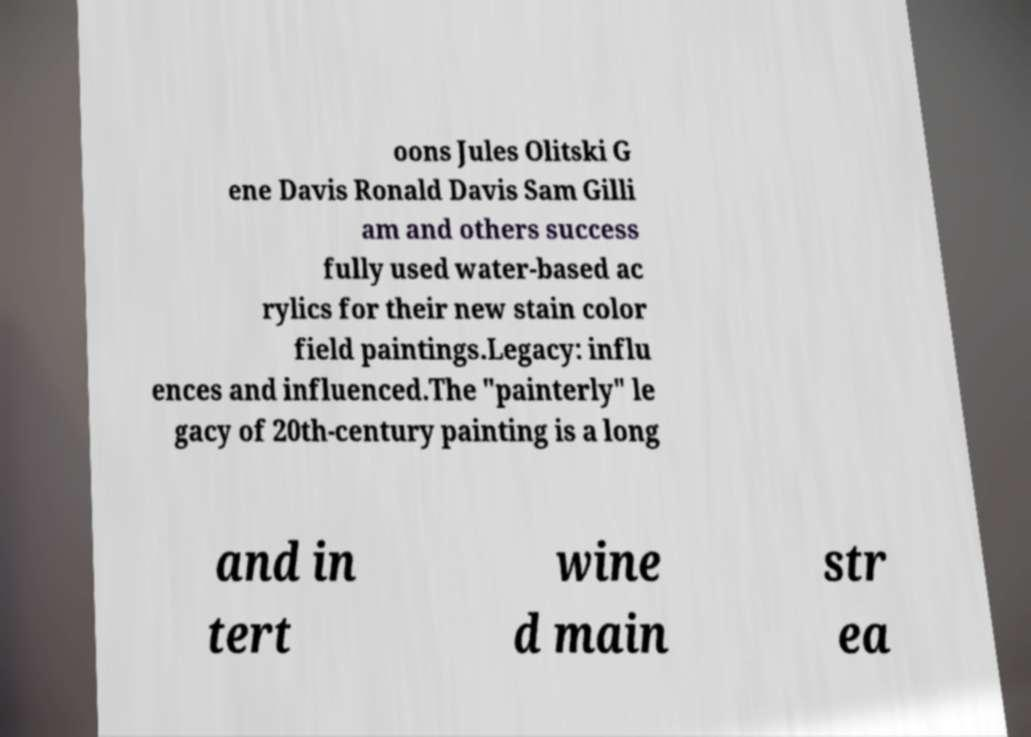Please identify and transcribe the text found in this image. oons Jules Olitski G ene Davis Ronald Davis Sam Gilli am and others success fully used water-based ac rylics for their new stain color field paintings.Legacy: influ ences and influenced.The "painterly" le gacy of 20th-century painting is a long and in tert wine d main str ea 